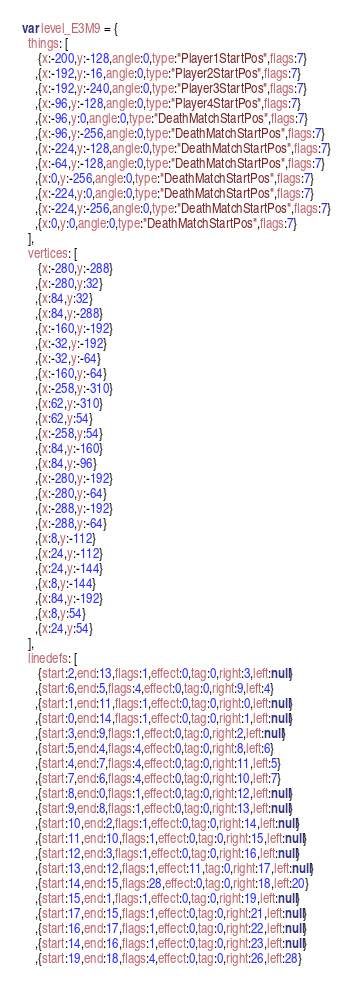Convert code to text. <code><loc_0><loc_0><loc_500><loc_500><_JavaScript_>var level_E3M9 = {
  things: [
     {x:-200,y:-128,angle:0,type:"Player1StartPos",flags:7}
    ,{x:-192,y:-16,angle:0,type:"Player2StartPos",flags:7}
    ,{x:-192,y:-240,angle:0,type:"Player3StartPos",flags:7}
    ,{x:-96,y:-128,angle:0,type:"Player4StartPos",flags:7}
    ,{x:-96,y:0,angle:0,type:"DeathMatchStartPos",flags:7}
    ,{x:-96,y:-256,angle:0,type:"DeathMatchStartPos",flags:7}
    ,{x:-224,y:-128,angle:0,type:"DeathMatchStartPos",flags:7}
    ,{x:-64,y:-128,angle:0,type:"DeathMatchStartPos",flags:7}
    ,{x:0,y:-256,angle:0,type:"DeathMatchStartPos",flags:7}
    ,{x:-224,y:0,angle:0,type:"DeathMatchStartPos",flags:7}
    ,{x:-224,y:-256,angle:0,type:"DeathMatchStartPos",flags:7}
    ,{x:0,y:0,angle:0,type:"DeathMatchStartPos",flags:7}
  ],
  vertices: [
     {x:-280,y:-288}
    ,{x:-280,y:32}
    ,{x:84,y:32}
    ,{x:84,y:-288}
    ,{x:-160,y:-192}
    ,{x:-32,y:-192}
    ,{x:-32,y:-64}
    ,{x:-160,y:-64}
    ,{x:-258,y:-310}
    ,{x:62,y:-310}
    ,{x:62,y:54}
    ,{x:-258,y:54}
    ,{x:84,y:-160}
    ,{x:84,y:-96}
    ,{x:-280,y:-192}
    ,{x:-280,y:-64}
    ,{x:-288,y:-192}
    ,{x:-288,y:-64}
    ,{x:8,y:-112}
    ,{x:24,y:-112}
    ,{x:24,y:-144}
    ,{x:8,y:-144}
    ,{x:84,y:-192}
    ,{x:8,y:54}
    ,{x:24,y:54}
  ],
  linedefs: [
     {start:2,end:13,flags:1,effect:0,tag:0,right:3,left:null}
    ,{start:6,end:5,flags:4,effect:0,tag:0,right:9,left:4}
    ,{start:1,end:11,flags:1,effect:0,tag:0,right:0,left:null}
    ,{start:0,end:14,flags:1,effect:0,tag:0,right:1,left:null}
    ,{start:3,end:9,flags:1,effect:0,tag:0,right:2,left:null}
    ,{start:5,end:4,flags:4,effect:0,tag:0,right:8,left:6}
    ,{start:4,end:7,flags:4,effect:0,tag:0,right:11,left:5}
    ,{start:7,end:6,flags:4,effect:0,tag:0,right:10,left:7}
    ,{start:8,end:0,flags:1,effect:0,tag:0,right:12,left:null}
    ,{start:9,end:8,flags:1,effect:0,tag:0,right:13,left:null}
    ,{start:10,end:2,flags:1,effect:0,tag:0,right:14,left:null}
    ,{start:11,end:10,flags:1,effect:0,tag:0,right:15,left:null}
    ,{start:12,end:3,flags:1,effect:0,tag:0,right:16,left:null}
    ,{start:13,end:12,flags:1,effect:11,tag:0,right:17,left:null}
    ,{start:14,end:15,flags:28,effect:0,tag:0,right:18,left:20}
    ,{start:15,end:1,flags:1,effect:0,tag:0,right:19,left:null}
    ,{start:17,end:15,flags:1,effect:0,tag:0,right:21,left:null}
    ,{start:16,end:17,flags:1,effect:0,tag:0,right:22,left:null}
    ,{start:14,end:16,flags:1,effect:0,tag:0,right:23,left:null}
    ,{start:19,end:18,flags:4,effect:0,tag:0,right:26,left:28}</code> 